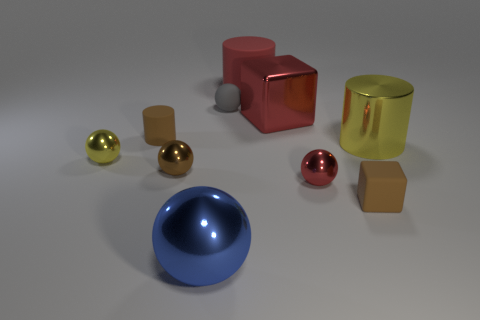What is the material of the red cylinder?
Provide a short and direct response. Rubber. What color is the thing that is behind the yellow sphere and to the right of the large red metal object?
Your answer should be compact. Yellow. Is the number of large metallic balls behind the red cylinder the same as the number of tiny yellow things that are on the right side of the small gray rubber object?
Give a very brief answer. Yes. There is a cylinder that is made of the same material as the blue thing; what color is it?
Offer a terse response. Yellow. There is a large shiny cylinder; is it the same color as the small thing on the left side of the tiny brown cylinder?
Your answer should be very brief. Yes. Are there any big metal things that are in front of the small brown rubber object that is in front of the rubber object on the left side of the blue shiny sphere?
Keep it short and to the point. Yes. What is the shape of the brown object that is made of the same material as the large blue object?
Provide a short and direct response. Sphere. What is the shape of the big blue object?
Your answer should be very brief. Sphere. There is a small brown matte thing behind the small yellow shiny thing; is its shape the same as the big rubber thing?
Offer a terse response. Yes. Are there more brown matte cylinders that are behind the tiny yellow thing than blocks that are in front of the large sphere?
Provide a short and direct response. Yes. 